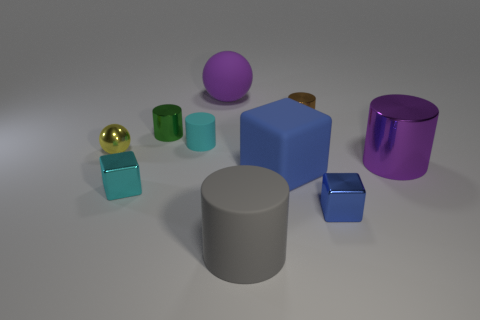Are there fewer rubber cylinders than large things?
Your answer should be compact. Yes. Is the small brown thing the same shape as the blue metallic thing?
Give a very brief answer. No. What number of objects are yellow shiny blocks or things in front of the yellow ball?
Keep it short and to the point. 5. How many small green metallic cylinders are there?
Give a very brief answer. 1. Are there any cyan matte cylinders that have the same size as the brown metal cylinder?
Offer a terse response. Yes. Are there fewer big rubber things that are to the left of the shiny ball than big brown balls?
Make the answer very short. No. Is the size of the matte ball the same as the blue matte cube?
Ensure brevity in your answer.  Yes. There is a purple thing that is the same material as the green thing; what is its size?
Offer a terse response. Large. How many objects are the same color as the large shiny cylinder?
Provide a short and direct response. 1. Is the number of big gray matte cylinders that are in front of the cyan cylinder less than the number of large purple shiny things left of the large purple sphere?
Provide a succinct answer. No. 